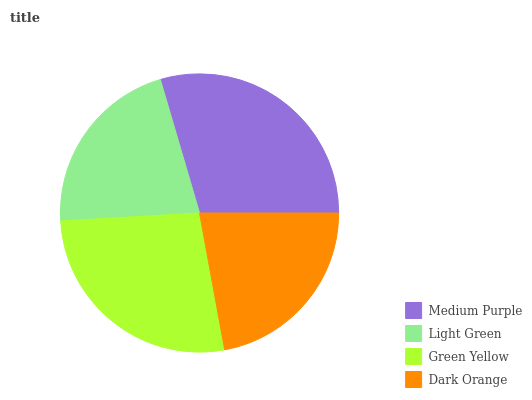Is Light Green the minimum?
Answer yes or no. Yes. Is Medium Purple the maximum?
Answer yes or no. Yes. Is Green Yellow the minimum?
Answer yes or no. No. Is Green Yellow the maximum?
Answer yes or no. No. Is Green Yellow greater than Light Green?
Answer yes or no. Yes. Is Light Green less than Green Yellow?
Answer yes or no. Yes. Is Light Green greater than Green Yellow?
Answer yes or no. No. Is Green Yellow less than Light Green?
Answer yes or no. No. Is Green Yellow the high median?
Answer yes or no. Yes. Is Dark Orange the low median?
Answer yes or no. Yes. Is Light Green the high median?
Answer yes or no. No. Is Green Yellow the low median?
Answer yes or no. No. 